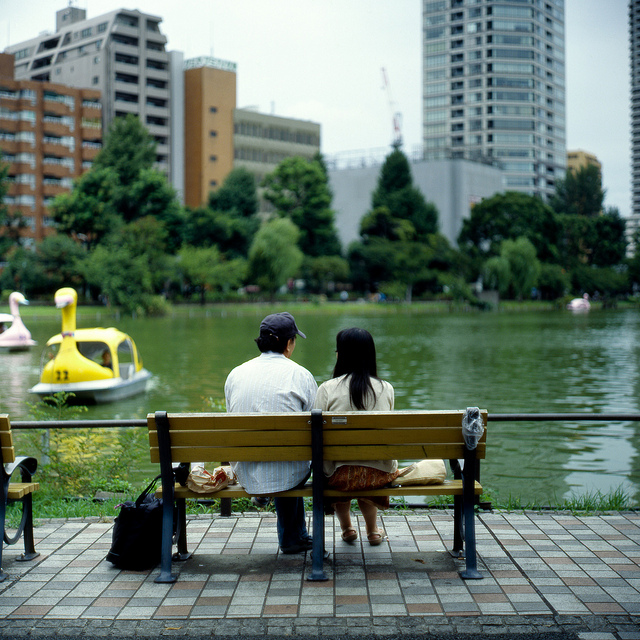Extract all visible text content from this image. 22 